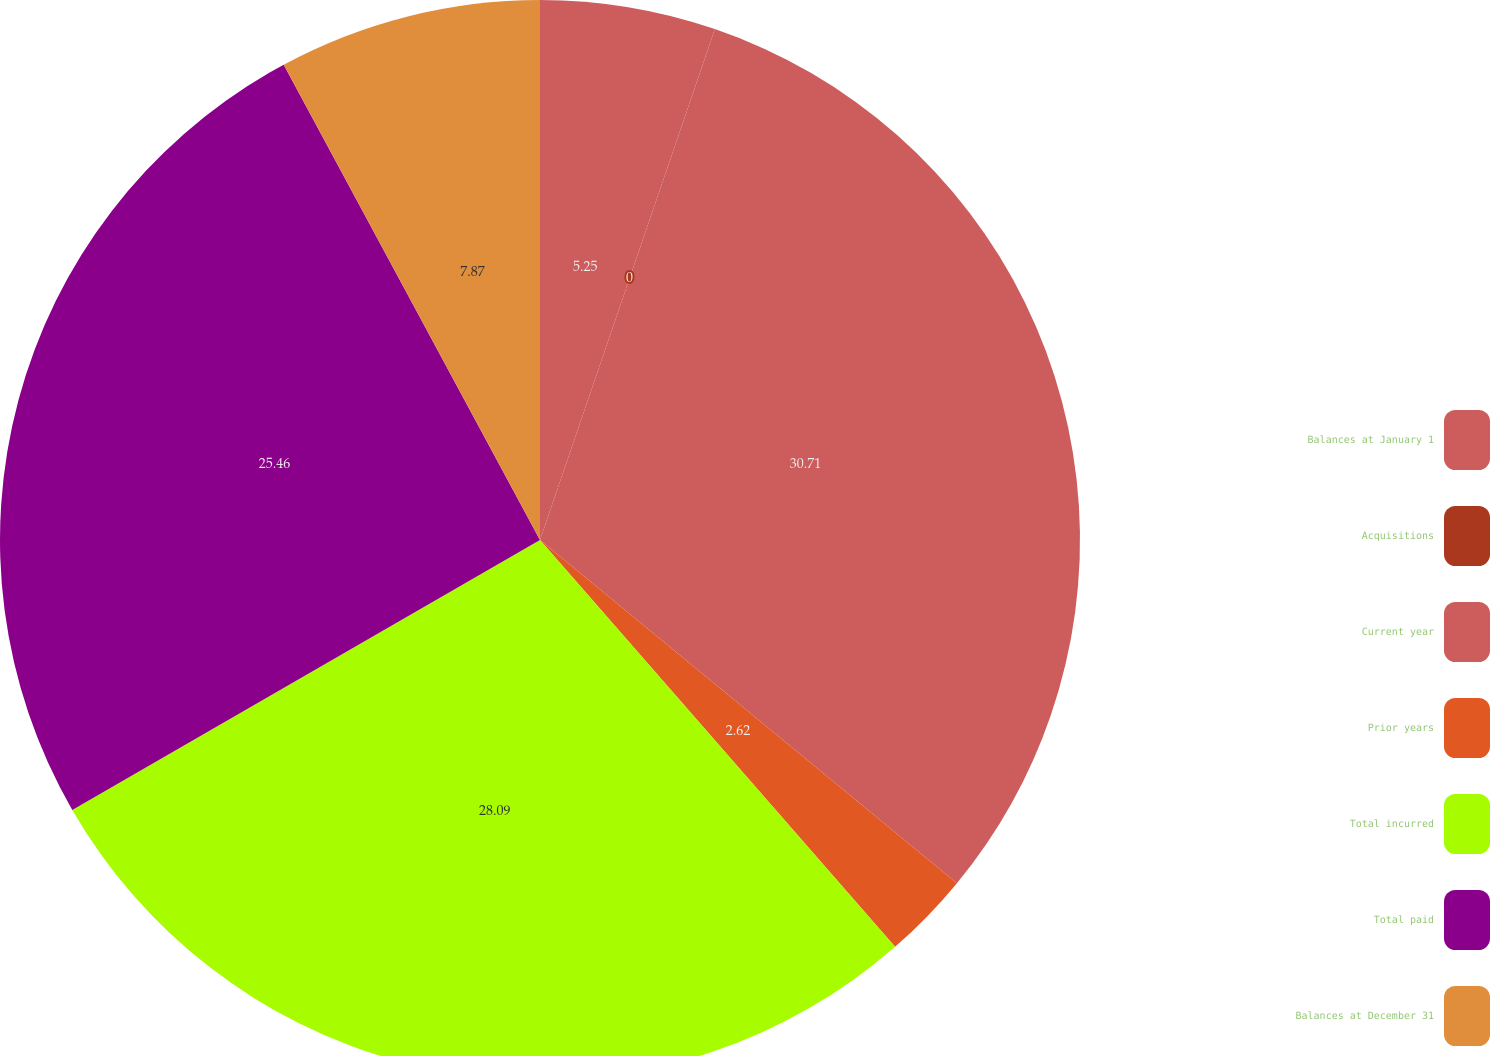Convert chart to OTSL. <chart><loc_0><loc_0><loc_500><loc_500><pie_chart><fcel>Balances at January 1<fcel>Acquisitions<fcel>Current year<fcel>Prior years<fcel>Total incurred<fcel>Total paid<fcel>Balances at December 31<nl><fcel>5.25%<fcel>0.0%<fcel>30.71%<fcel>2.62%<fcel>28.09%<fcel>25.46%<fcel>7.87%<nl></chart> 